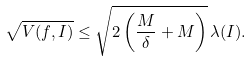Convert formula to latex. <formula><loc_0><loc_0><loc_500><loc_500>\sqrt { V ( f , I ) } \leq \sqrt { 2 \left ( \frac { M } { \delta } + M \right ) } \, \lambda ( I ) .</formula> 